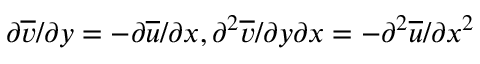<formula> <loc_0><loc_0><loc_500><loc_500>\partial \overline { v } / { \partial y } = - \partial \overline { u } / { \partial x } , \partial ^ { 2 } \overline { v } / { \partial y \partial x } = - \partial ^ { 2 } \overline { u } / { \partial x ^ { 2 } }</formula> 